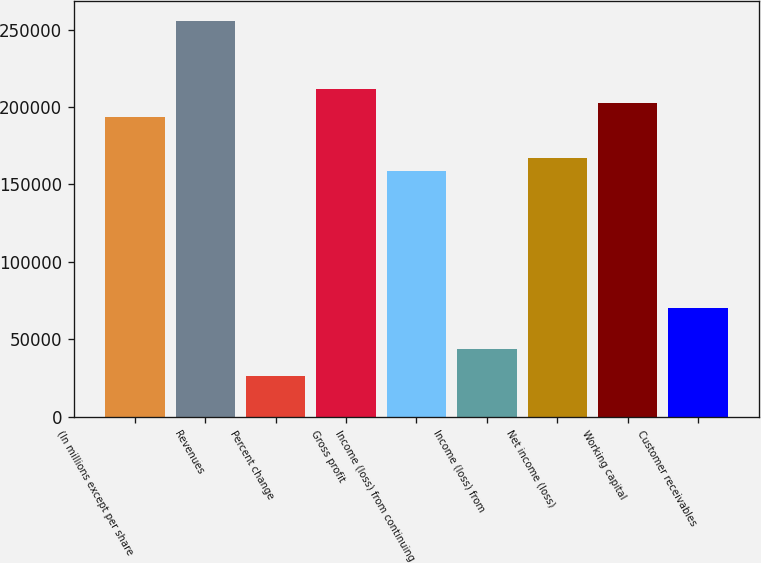<chart> <loc_0><loc_0><loc_500><loc_500><bar_chart><fcel>(In millions except per share<fcel>Revenues<fcel>Percent change<fcel>Gross profit<fcel>Income (loss) from continuing<fcel>Income (loss) from<fcel>Net income (loss)<fcel>Working capital<fcel>Customer receivables<nl><fcel>193710<fcel>255345<fcel>26415.2<fcel>211320<fcel>158490<fcel>44025.1<fcel>167295<fcel>202515<fcel>70440.1<nl></chart> 